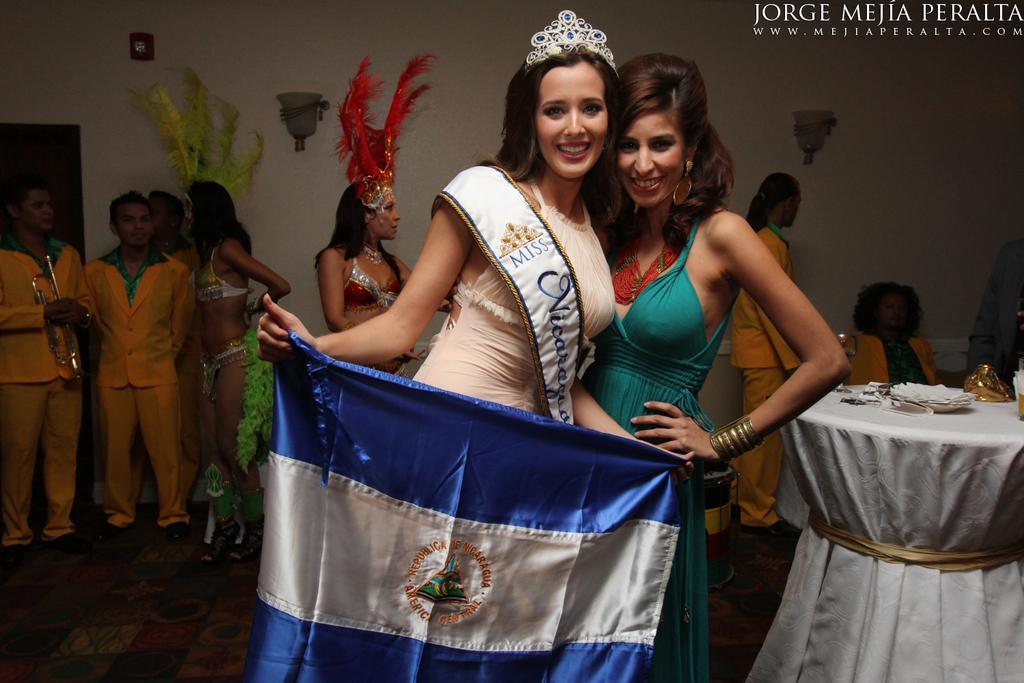In one or two sentences, can you explain what this image depicts? In the center of the image we can see people wearing costumes. The lady standing in the center is wearing a crown and holding a flag in her hand. On the right there is a table and we can see things placed on the table. In the background there is a wall and there are lights placed on the wall. 